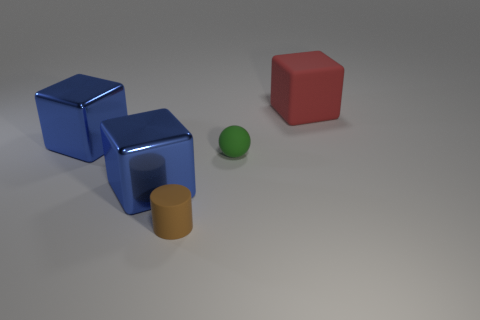Is there anything else that is the same shape as the tiny brown rubber thing?
Offer a terse response. No. What color is the matte thing that is behind the matte cylinder and in front of the red matte thing?
Offer a very short reply. Green. There is a blue metal block behind the small thing that is behind the brown matte thing; is there a big red object that is on the right side of it?
Provide a short and direct response. Yes. How many things are either blue things or big objects?
Your answer should be very brief. 3. Is the green ball made of the same material as the large blue thing that is in front of the green ball?
Your answer should be compact. No. Is there any other thing that is the same color as the tiny cylinder?
Keep it short and to the point. No. How many things are things left of the rubber block or large blue metallic blocks behind the green rubber thing?
Provide a succinct answer. 4. There is a big object that is both to the left of the rubber cylinder and behind the tiny green sphere; what shape is it?
Provide a short and direct response. Cube. There is a big object that is on the right side of the brown cylinder; how many red rubber objects are to the left of it?
Provide a succinct answer. 0. How many objects are large objects to the left of the large matte thing or small blue things?
Your response must be concise. 2. 